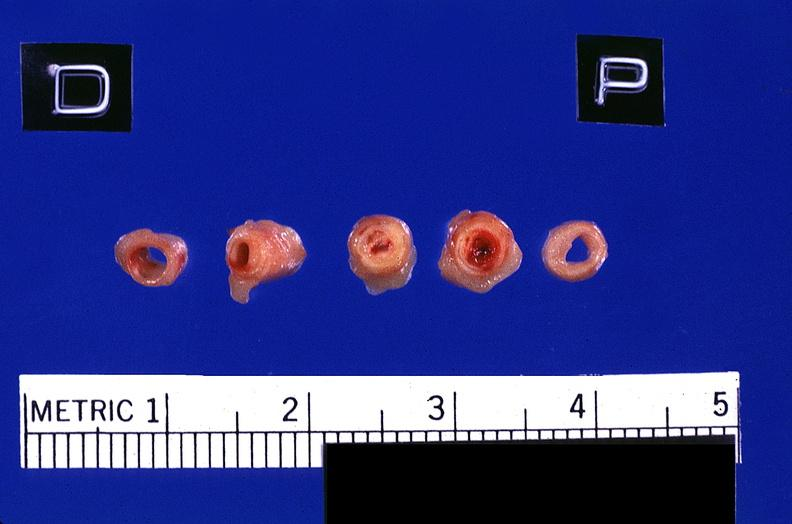does intraductal papillomatosis show coronary artery with atherosclerosis and thrombotic occlusion?
Answer the question using a single word or phrase. No 